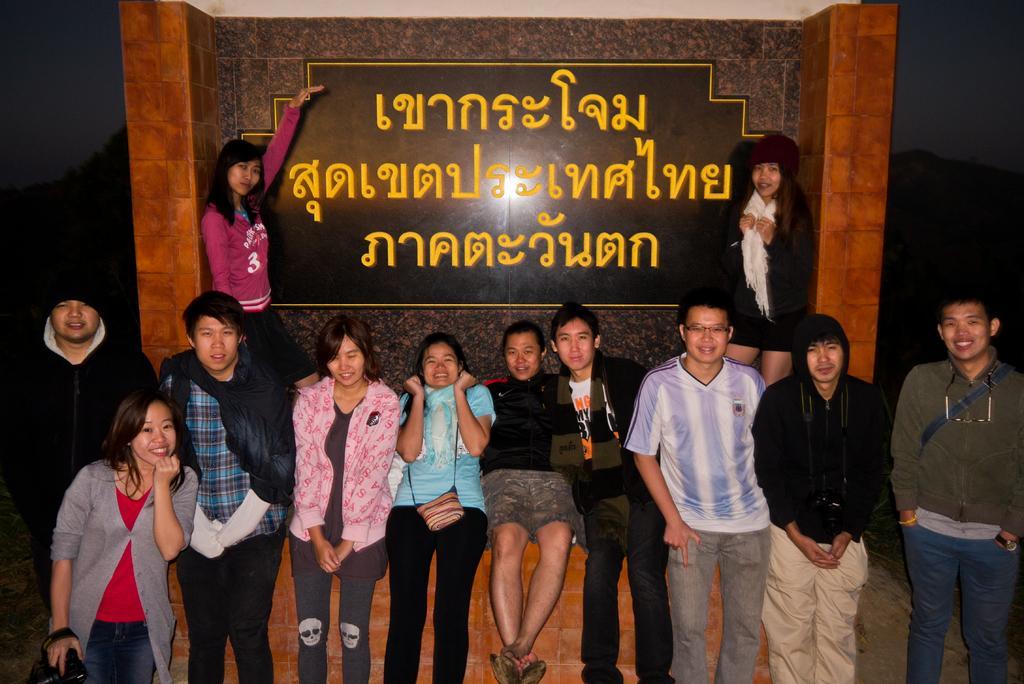How would you summarize this image in a sentence or two? In the foreground of the image there are people. In the background of the image there are two women standing. There is a wall. There is a board with some text. 